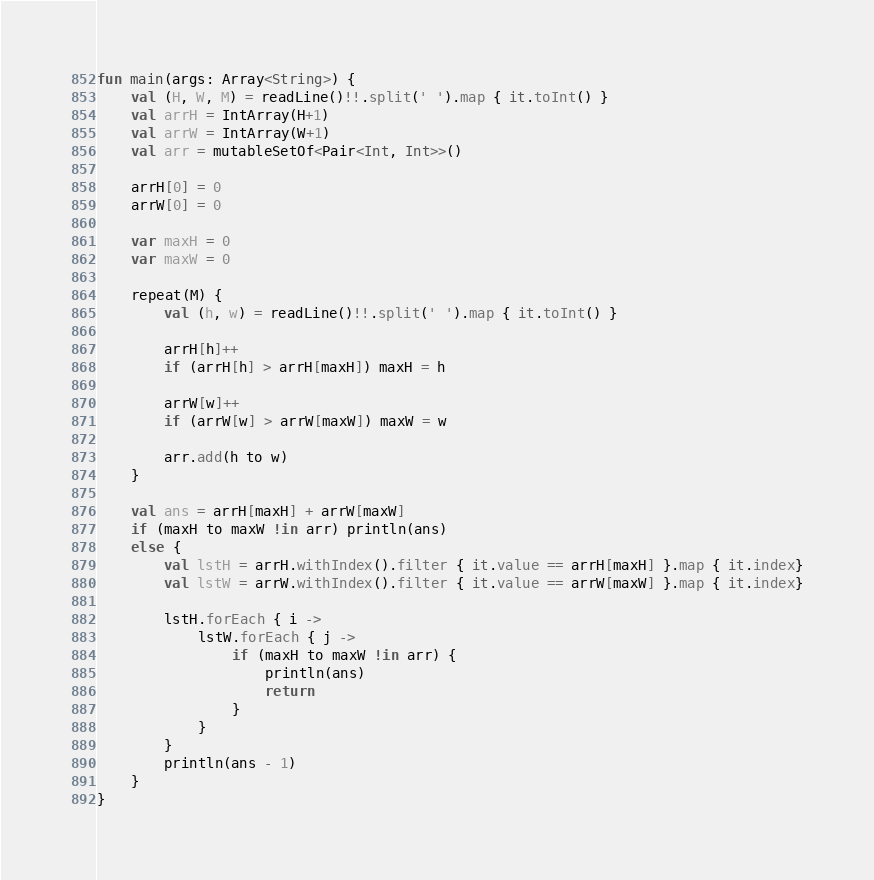Convert code to text. <code><loc_0><loc_0><loc_500><loc_500><_Kotlin_>fun main(args: Array<String>) {
    val (H, W, M) = readLine()!!.split(' ').map { it.toInt() }
    val arrH = IntArray(H+1)
    val arrW = IntArray(W+1)
    val arr = mutableSetOf<Pair<Int, Int>>()

    arrH[0] = 0
    arrW[0] = 0

    var maxH = 0
    var maxW = 0

    repeat(M) {
        val (h, w) = readLine()!!.split(' ').map { it.toInt() }

        arrH[h]++
        if (arrH[h] > arrH[maxH]) maxH = h

        arrW[w]++
        if (arrW[w] > arrW[maxW]) maxW = w

        arr.add(h to w)
    }

    val ans = arrH[maxH] + arrW[maxW]
    if (maxH to maxW !in arr) println(ans)
    else {
        val lstH = arrH.withIndex().filter { it.value == arrH[maxH] }.map { it.index}
        val lstW = arrW.withIndex().filter { it.value == arrW[maxW] }.map { it.index}

        lstH.forEach { i ->
            lstW.forEach { j ->
                if (maxH to maxW !in arr) {
                    println(ans)
                    return
                }
            }
        }
        println(ans - 1)
    }
}
</code> 